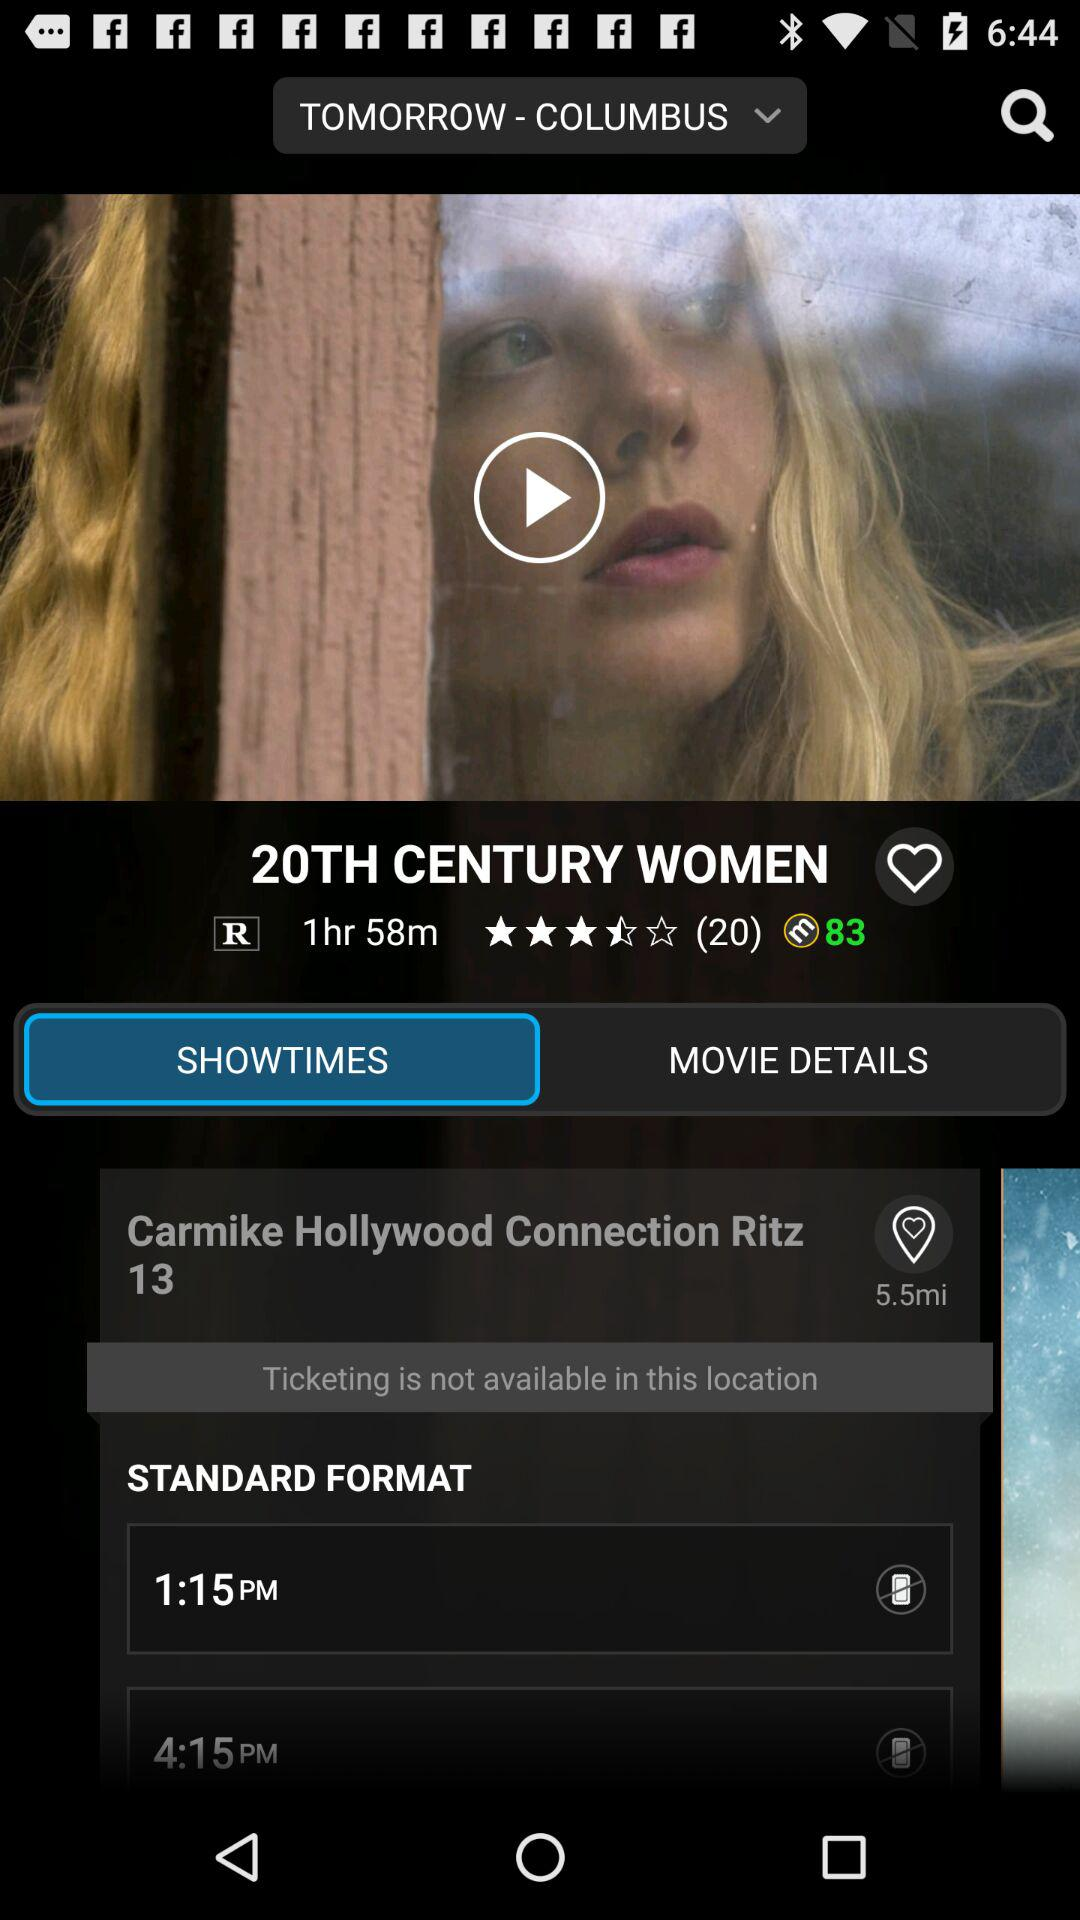How many ratings did "20TH CENTURY WOMEN" movie get? The movie gets 3.5 stars. 